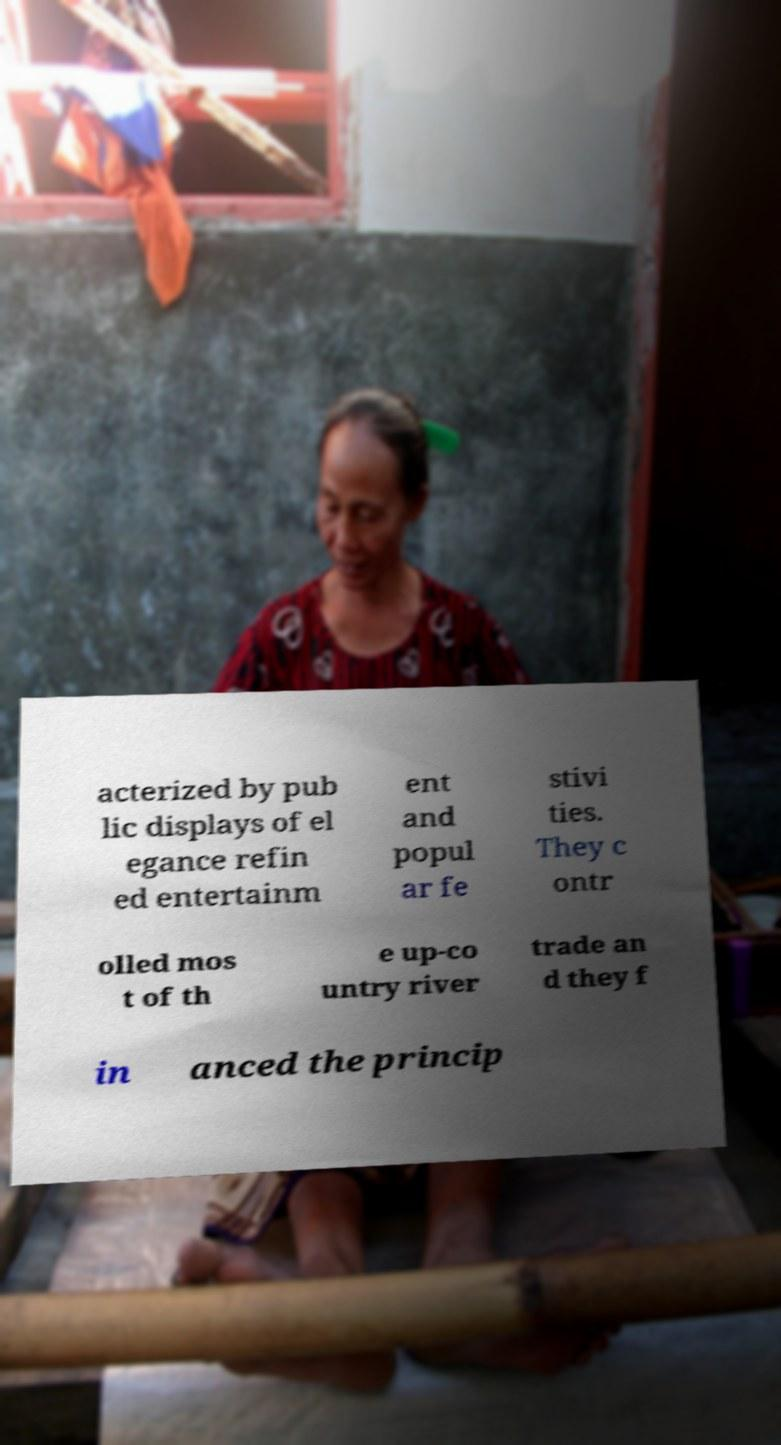Please identify and transcribe the text found in this image. acterized by pub lic displays of el egance refin ed entertainm ent and popul ar fe stivi ties. They c ontr olled mos t of th e up-co untry river trade an d they f in anced the princip 